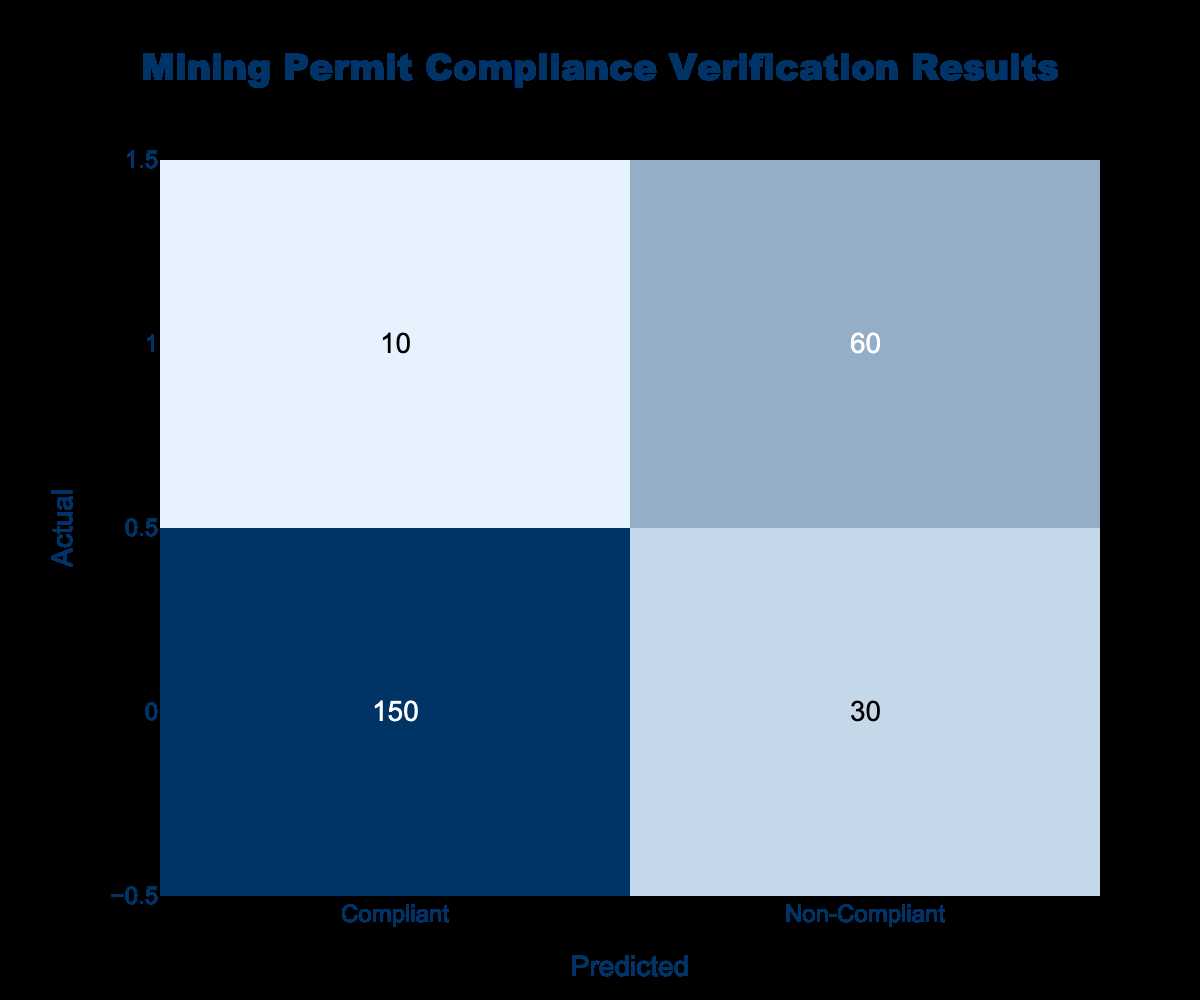What is the total number of compliant cases? The compliant cases are represented in the row labeled "Compliant." There are 150 cases that are compliant, so we simply read off this number directly from the table.
Answer: 150 How many non-compliant cases were predicted as compliant? To find the non-compliant cases predicted as compliant, we refer to the cell at the intersection of the "Non-Compliant" actual row and "Compliant" predicted column, which shows 10 cases.
Answer: 10 What is the total number of cases evaluated? To find the total number of cases, we sum all the values in the table: (150 + 30 + 10 + 60) = 250. This totals all compliant and non-compliant counts from both actual and predicted categories.
Answer: 250 What is the proportion of compliant cases out of the total evaluated cases? We have 150 compliant cases out of 250 total cases. The proportion is calculated by dividing compliant cases by the total cases: 150 / 250 = 0.6. Therefore, the proportion is 0.6 or 60%.
Answer: 0.6 Is the number of non-compliant cases greater than the number of compliant cases? To answer this, we compare non-compliant cases (30 + 60 = 90) with compliant cases (150). Since 90 is less than 150, the statement is false.
Answer: No What is the difference between the number of compliant predictions and non-compliant predictions? We calculate the number of compliant predictions (150 + 10 = 160) and the number of non-compliant predictions (30 + 60 = 90). The difference is 160 - 90 = 70.
Answer: 70 If we sum compliant and non-compliant cases predicted correctly, what do we get? The correctly predicted compliant cases are 150, and the correctly predicted non-compliant cases are 60. Summing these gives 150 + 60 = 210.
Answer: 210 What percentage of actual compliant cases were correctly predicted? The actual compliant cases are 150 and the correctly predicted compliant cases are also 150. To find the percentage, we calculate (150 / 150) * 100 = 100%. Therefore, all actual compliant cases were correctly predicted.
Answer: 100% How many actual non-compliant cases were incorrectly predicted as compliant? The actual non-compliant cases that were incorrectly predicted as compliant are represented in the table as 10; this is the count of cases that were non-compliant but predicted to be compliant.
Answer: 10 